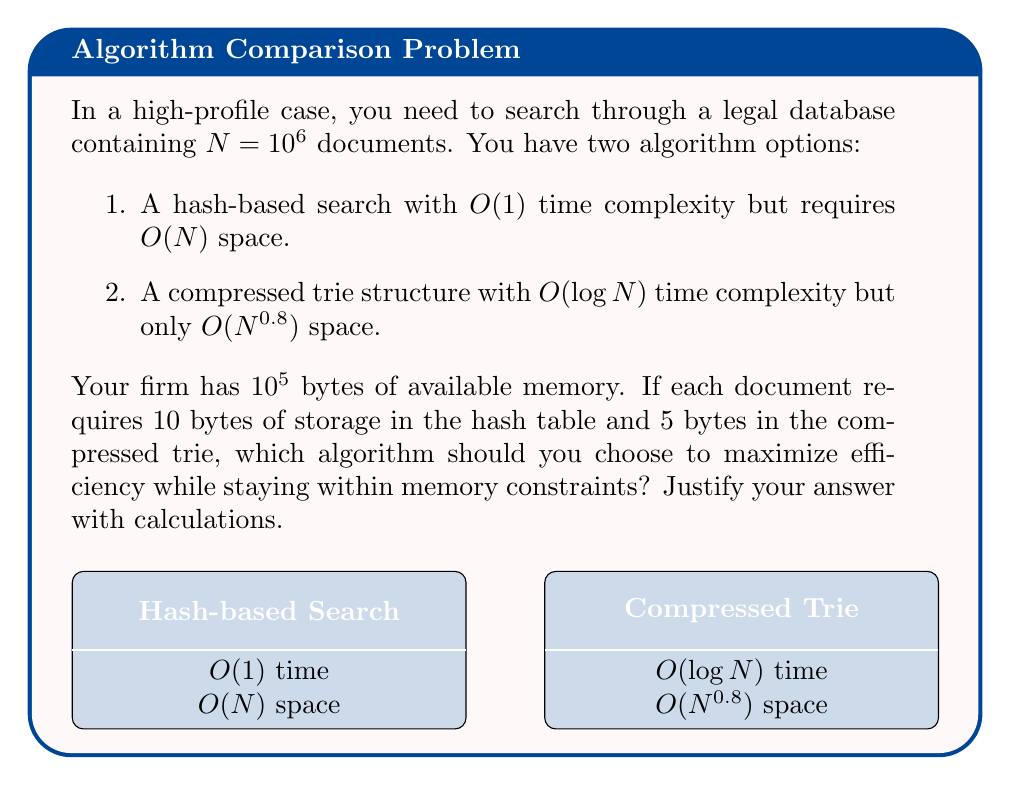Solve this math problem. Let's analyze this step-by-step:

1. Calculate the memory required for the hash-based search:
   $$10 \text{ bytes} \times 10^6 \text{ documents} = 10^7 \text{ bytes}$$

2. Calculate the memory required for the compressed trie:
   $$5 \text{ bytes} \times (10^6)^{0.8} = 5 \times 10^{4.8} \approx 3.16 \times 10^5 \text{ bytes}$$

3. Compare with available memory:
   - Hash-based search: $10^7 \text{ bytes} > 10^5 \text{ bytes}$ (exceeds limit)
   - Compressed trie: $3.16 \times 10^5 \text{ bytes} < 10^5 \text{ bytes}$ (within limit)

4. Time complexity comparison:
   - Hash-based search: $O(1)$ (constant time)
   - Compressed trie: $O(\log N) = O(\log 10^6) \approx O(20)$ (logarithmic time)

5. Decision analysis:
   The hash-based search, while offering constant time complexity, exceeds the memory constraint by two orders of magnitude. The compressed trie, on the other hand, fits within the memory limit and offers a reasonable logarithmic time complexity.

As a corporate lawyer dealing with high-profile cases, the ability to work within resource constraints while maintaining efficient performance is crucial. The compressed trie offers a balanced solution that meets memory requirements and provides acceptable search speed.
Answer: Choose the compressed trie algorithm: it fits within memory constraints (using $\approx 3.16 \times 10^5$ bytes) and offers $O(\log N)$ time complexity. 